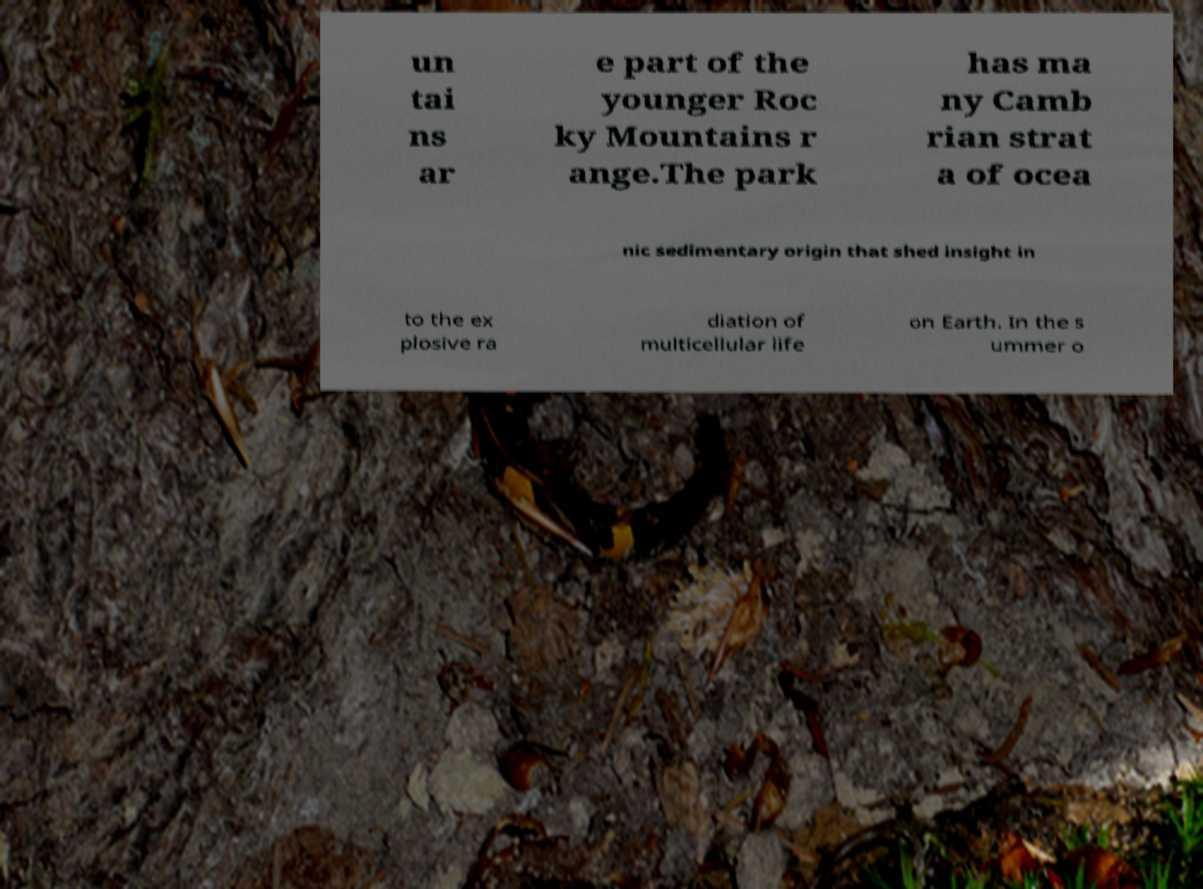Please read and relay the text visible in this image. What does it say? un tai ns ar e part of the younger Roc ky Mountains r ange.The park has ma ny Camb rian strat a of ocea nic sedimentary origin that shed insight in to the ex plosive ra diation of multicellular life on Earth. In the s ummer o 